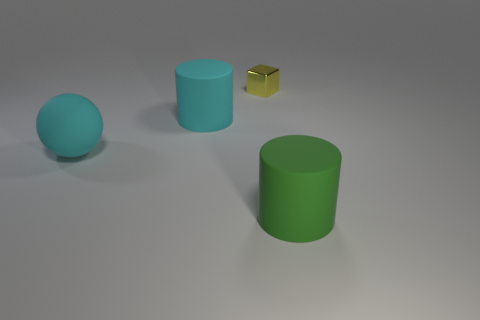Add 1 rubber cylinders. How many objects exist? 5 Subtract 1 cylinders. How many cylinders are left? 1 Subtract all green cylinders. How many cylinders are left? 1 Subtract 0 purple balls. How many objects are left? 4 Subtract all spheres. How many objects are left? 3 Subtract all blue spheres. Subtract all purple cubes. How many spheres are left? 1 Subtract all red spheres. How many cyan cylinders are left? 1 Subtract all cylinders. Subtract all large cyan balls. How many objects are left? 1 Add 2 tiny metal objects. How many tiny metal objects are left? 3 Add 4 purple shiny blocks. How many purple shiny blocks exist? 4 